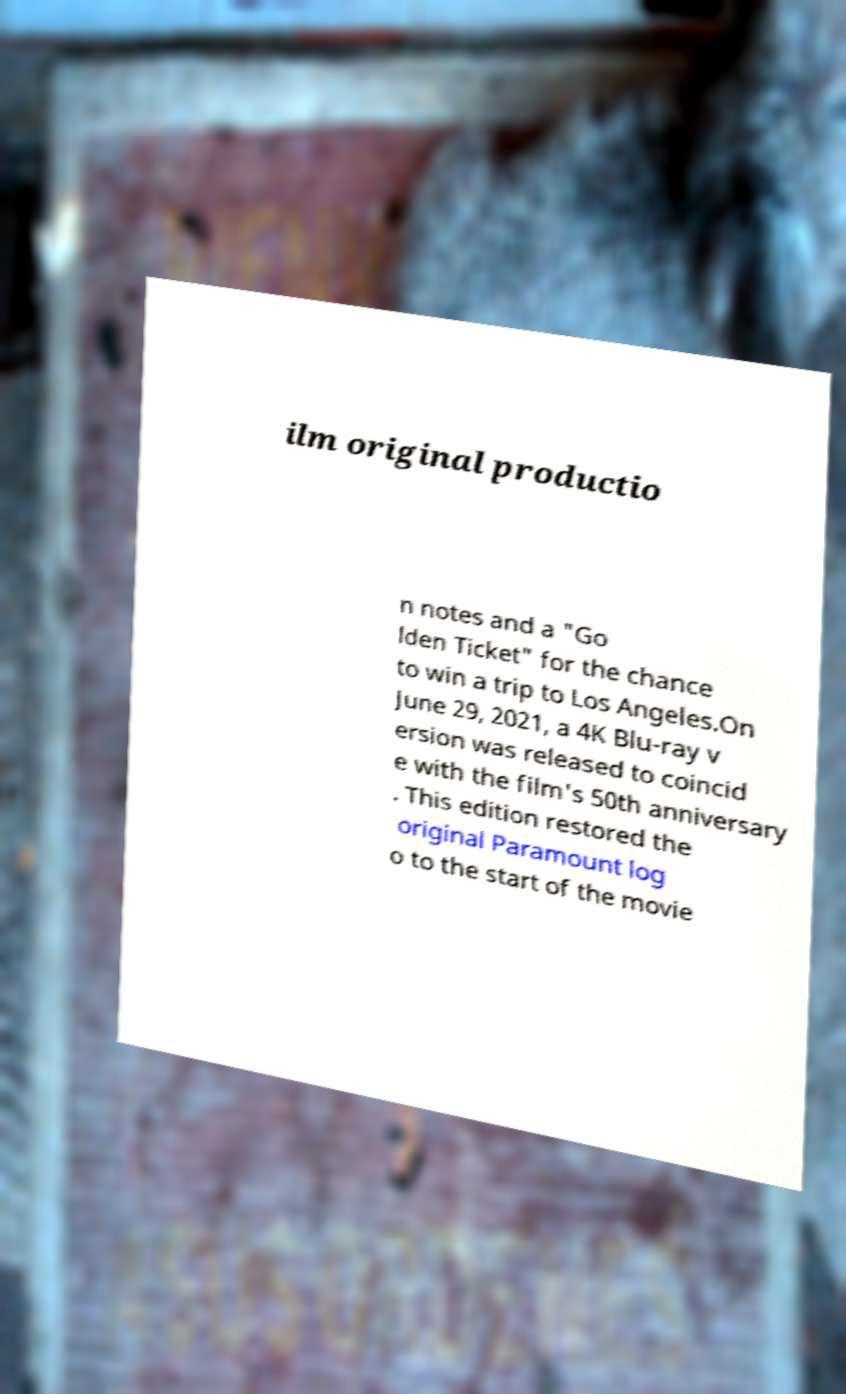There's text embedded in this image that I need extracted. Can you transcribe it verbatim? ilm original productio n notes and a "Go lden Ticket" for the chance to win a trip to Los Angeles.On June 29, 2021, a 4K Blu-ray v ersion was released to coincid e with the film's 50th anniversary . This edition restored the original Paramount log o to the start of the movie 